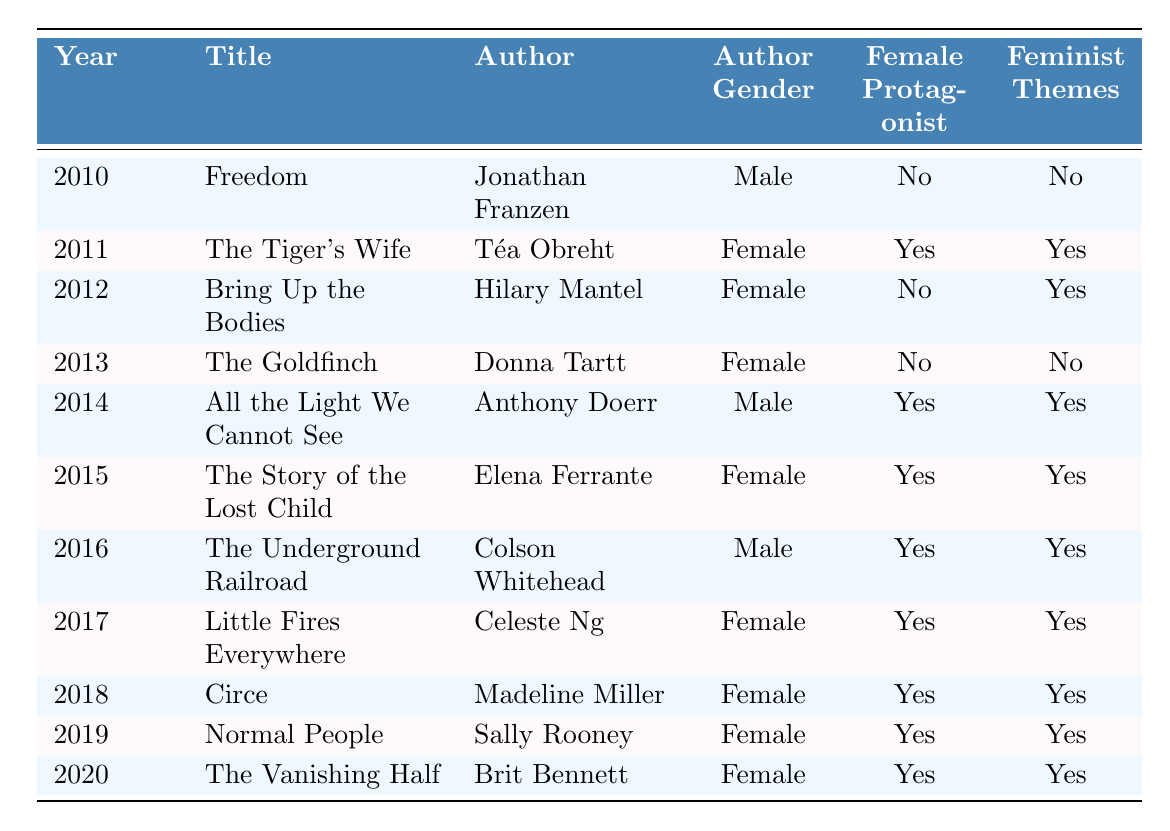What is the title of the book with a female protagonist published in 2015? In the table, we see that the book "The Story of the Lost Child" by Elena Ferrante, published in 2015, has a female protagonist.
Answer: The Story of the Lost Child What is the total number of weeks the book "All the Light We Cannot See" remained on the bestseller list? The table indicates that "All the Light We Cannot See" by Anthony Doerr was on the bestseller list for 30 weeks.
Answer: 30 weeks Which author had the highest number of weeks on the bestseller list? By examining the weeks on the bestseller list for each entry, we find that "The Goldfinch" by Donna Tartt had the highest number of weeks at 24, compared to other books; however, "All the Light We Cannot See" was on the list for 30 weeks. So, Anthony Doerr is the author with the highest weeks on the list.
Answer: Anthony Doerr Which year had the most books featuring feminist themes? The table shows that the years 2011, 2014, 2015, 2016, 2017, 2018, 2019, and 2020 all have books with feminist themes. By counting these entries, we find there are eight entries featuring feminist themes.
Answer: 2011, 2014, 2015, 2016, 2017, 2018, 2019, 2020 What percentage of the books had female protagonists? There are a total of 11 entries in the table, and 7 of those have female protagonists (years 2011, 2015, 2016, 2017, 2018, 2019, 2020). To find the percentage, we calculate (7/11) * 100, which yields approximately 63.64%.
Answer: Approximately 63.64% What is the count of books authored by female authors that feature feminist themes? Looking at the table, the entries for books written by female authors that also have feminist themes are: "The Tiger's Wife" (2011), "Bring Up the Bodies" (2012), "The Story of the Lost Child" (2015), "Little Fires Everywhere" (2017), "Circe" (2018), "Normal People" (2019), and "The Vanishing Half" (2020). This gives us a total of 6 books.
Answer: 6 books Which book was released in 2012 and what themes did it feature? From the table, in 2012, the book "Bring Up the Bodies" by Hilary Mantel was released, and it features feminist themes but does not have a female protagonist.
Answer: Bring Up the Bodies; Feminist themes present, no female protagonist Is "Normal People" a book with both a female protagonist and feminist themes? By checking the table, we see that "Normal People" by Sally Rooney has a female protagonist and also features feminist themes.
Answer: Yes, both present 